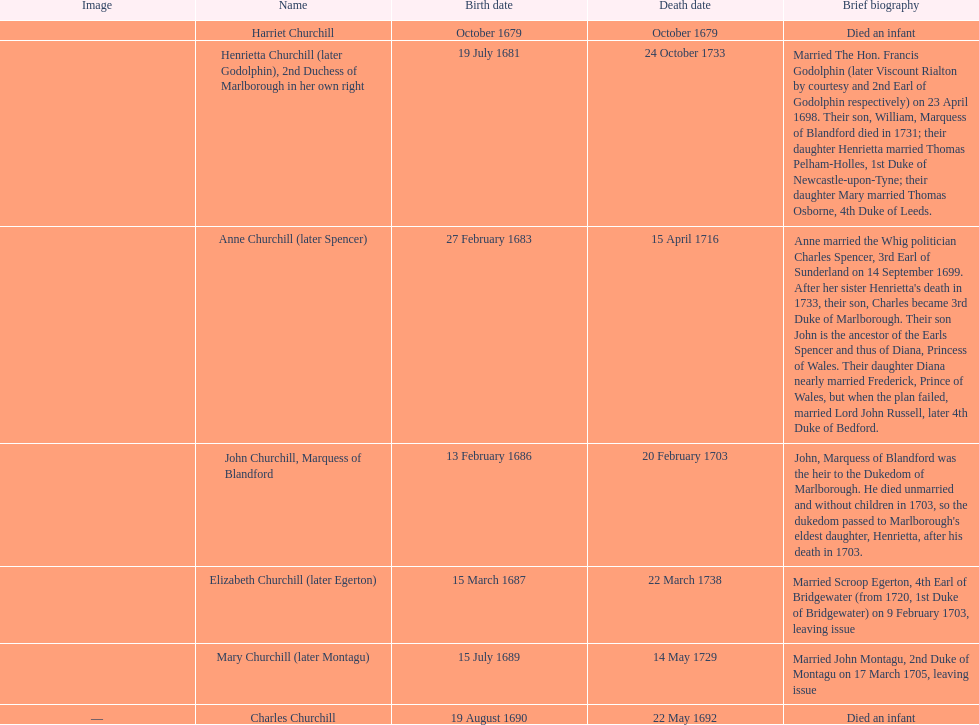What was the birthdate of sarah churchill's first child? October 1679. 